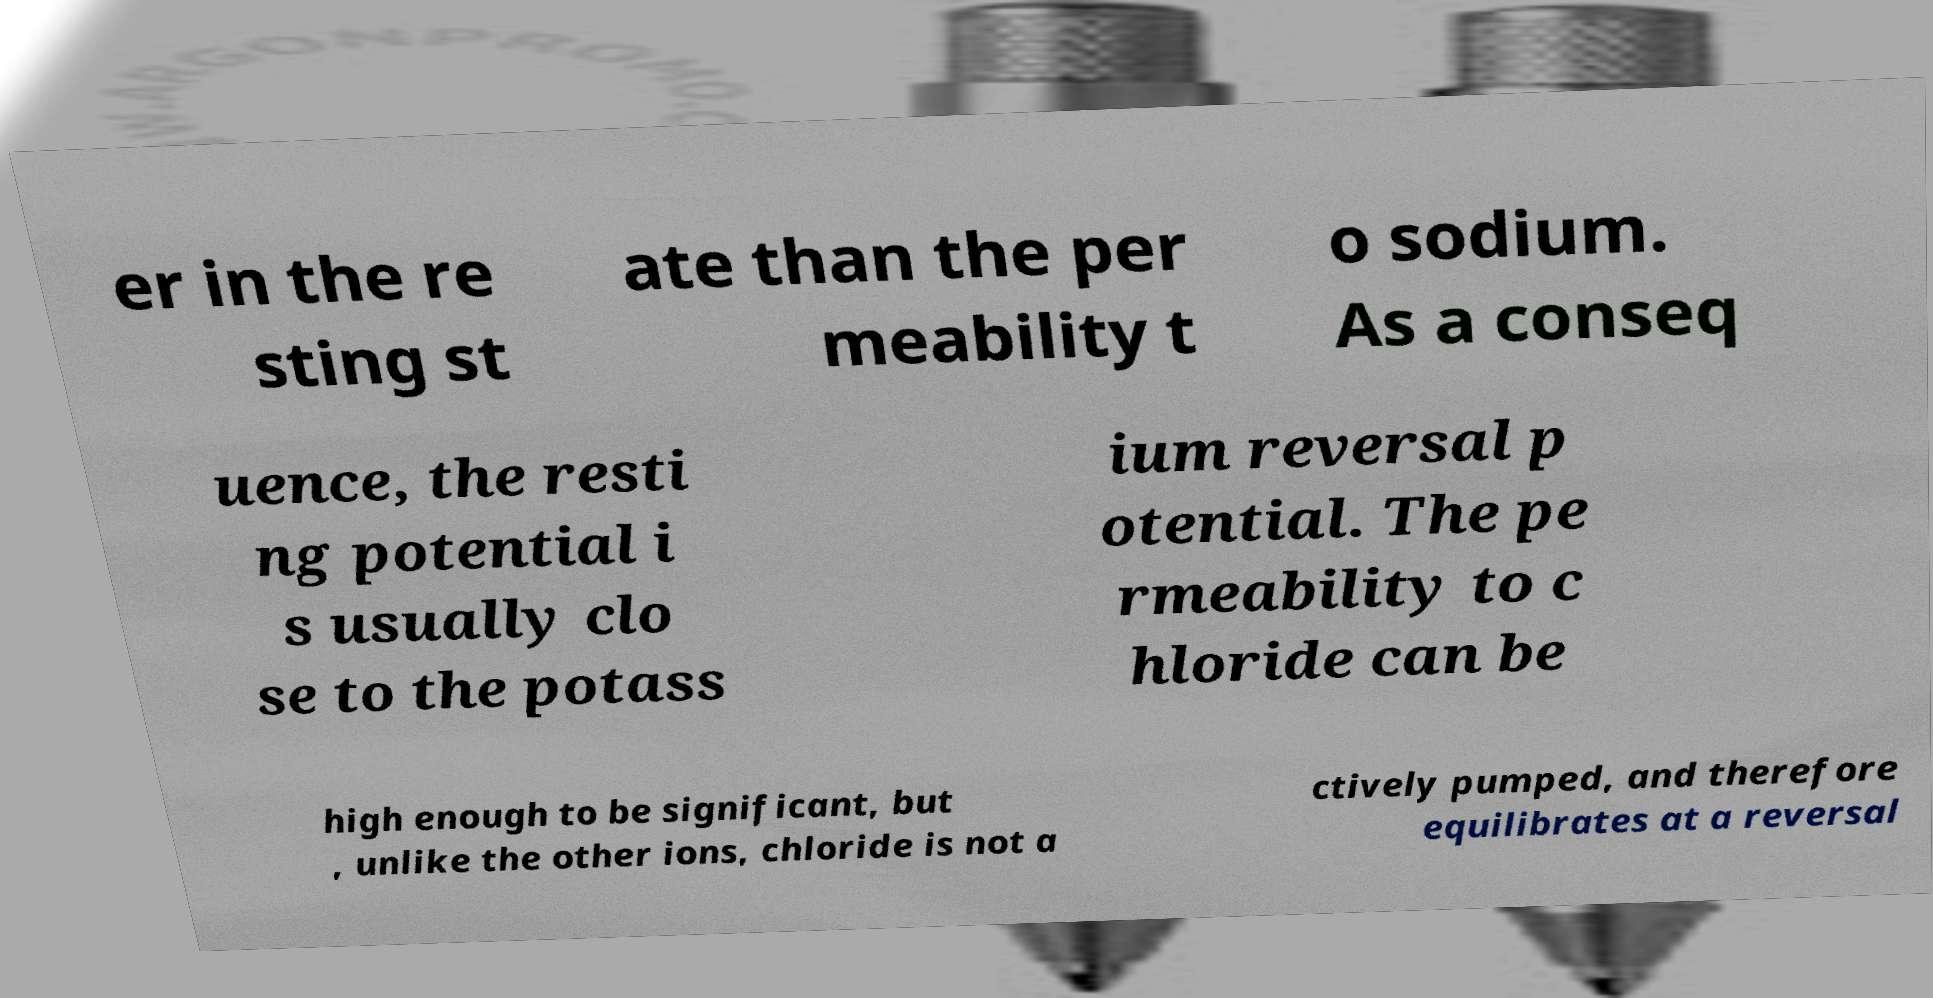I need the written content from this picture converted into text. Can you do that? er in the re sting st ate than the per meability t o sodium. As a conseq uence, the resti ng potential i s usually clo se to the potass ium reversal p otential. The pe rmeability to c hloride can be high enough to be significant, but , unlike the other ions, chloride is not a ctively pumped, and therefore equilibrates at a reversal 